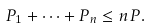<formula> <loc_0><loc_0><loc_500><loc_500>P _ { 1 } + \cdots + P _ { n } \leq n P .</formula> 